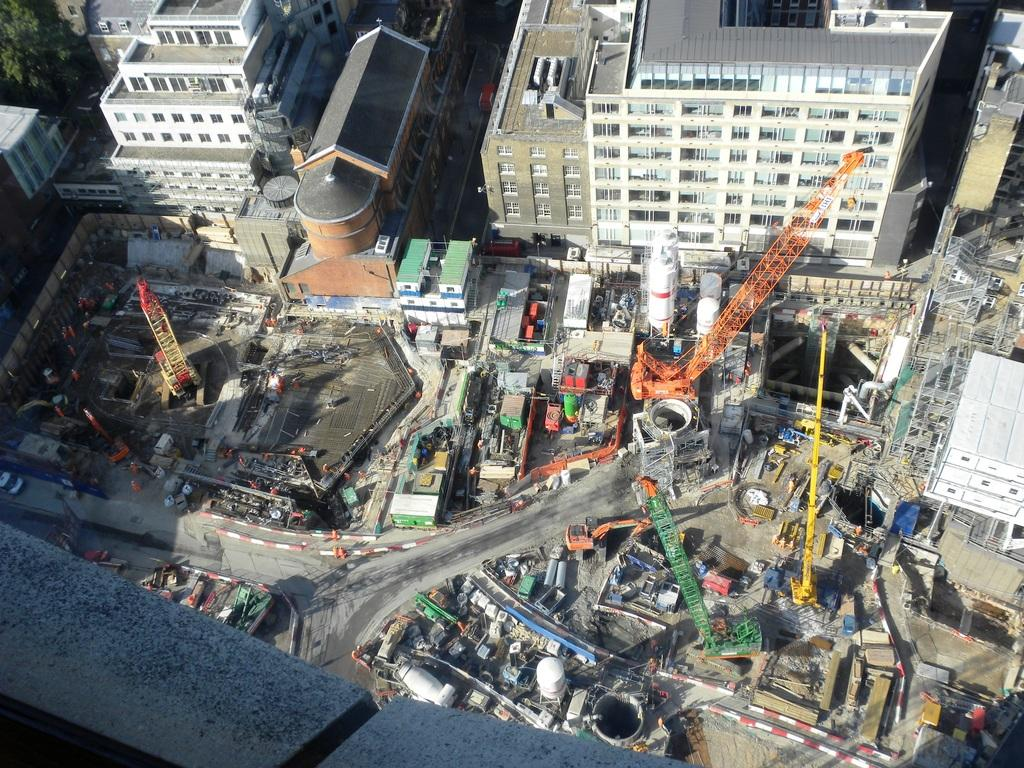What type of natural element is present in the image? There is a tree in the image. What type of man-made structures can be seen in the image? There are buildings in the image. What feature of the buildings is visible in the image? There are windows visible in the image. What type of transportation is present in the image? There are vehicles in the image. What type of sponge is being used to clean the windows in the image? There is no sponge visible in the image, and no cleaning activity is taking place. What beliefs are being expressed by the vehicles in the image? Vehicles do not express beliefs; they are inanimate objects used for transportation. 